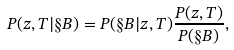Convert formula to latex. <formula><loc_0><loc_0><loc_500><loc_500>P ( z , T | \S B ) = P ( \S B | z , T ) \frac { P ( z , T ) } { P ( \S B ) } ,</formula> 